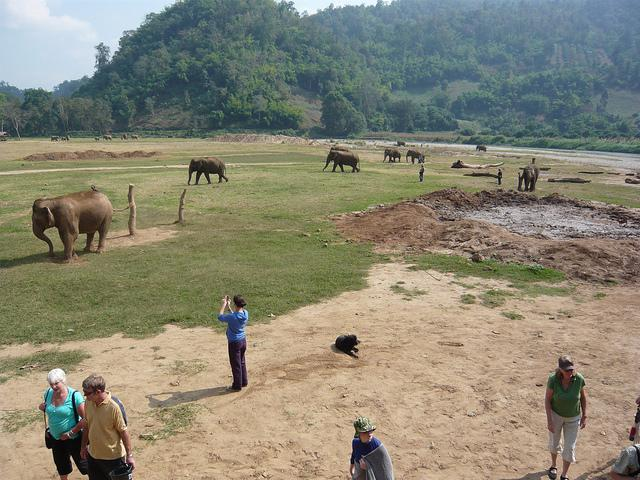The person holding the camera is wearing what color shirt? blue 